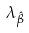Convert formula to latex. <formula><loc_0><loc_0><loc_500><loc_500>\lambda _ { \hat { \beta } }</formula> 